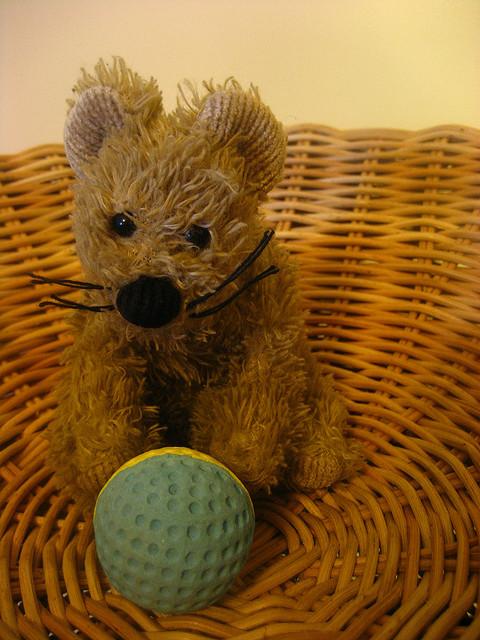Are the toys scattered on the floor?
Short answer required. No. Is that a real animal?
Short answer required. No. What is in front of the animal?
Quick response, please. Ball. 